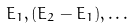<formula> <loc_0><loc_0><loc_500><loc_500>E _ { 1 } , ( E _ { 2 } - E _ { 1 } ) , \dots</formula> 